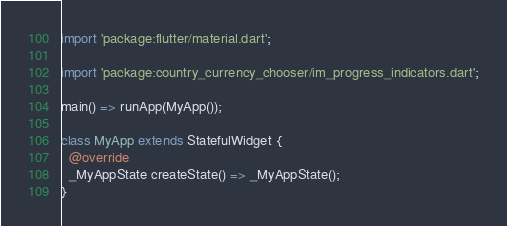<code> <loc_0><loc_0><loc_500><loc_500><_Dart_>import 'package:flutter/material.dart';

import 'package:country_currency_chooser/im_progress_indicators.dart';

main() => runApp(MyApp());

class MyApp extends StatefulWidget {
  @override
  _MyAppState createState() => _MyAppState();
}
</code> 